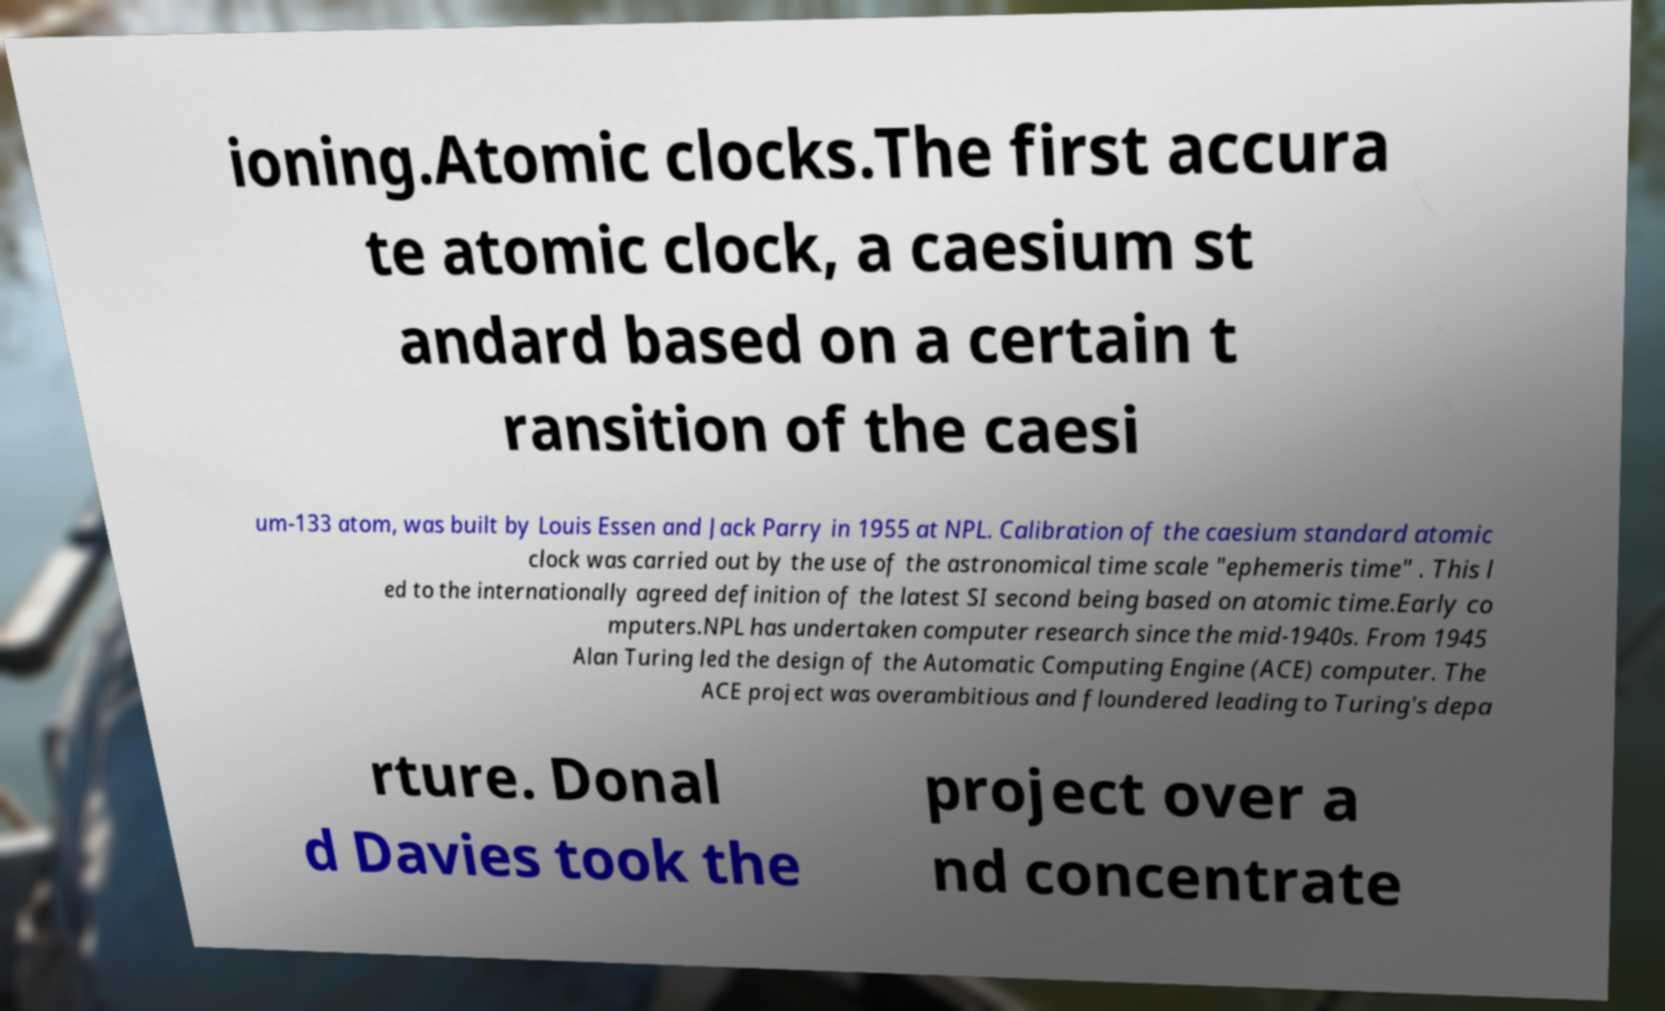Please identify and transcribe the text found in this image. ioning.Atomic clocks.The first accura te atomic clock, a caesium st andard based on a certain t ransition of the caesi um-133 atom, was built by Louis Essen and Jack Parry in 1955 at NPL. Calibration of the caesium standard atomic clock was carried out by the use of the astronomical time scale "ephemeris time" . This l ed to the internationally agreed definition of the latest SI second being based on atomic time.Early co mputers.NPL has undertaken computer research since the mid-1940s. From 1945 Alan Turing led the design of the Automatic Computing Engine (ACE) computer. The ACE project was overambitious and floundered leading to Turing's depa rture. Donal d Davies took the project over a nd concentrate 